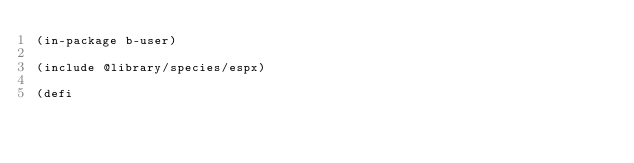Convert code to text. <code><loc_0><loc_0><loc_500><loc_500><_Lisp_>(in-package b-user)

(include @library/species/espx)

(defi</code> 